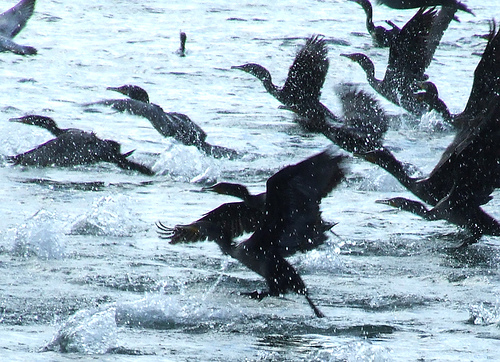Can you describe the overall activity of the birds in the water? The birds appear to be energetically interacting with the water, some are taking off into the air while others are diving or flapping their wings on the surface, creating a dynamic and lively scene. Can you zoom in on a single bird and describe its actions in detail? Upon focusing on a single bird, you can see it extends its wings wide while skimming across the water. The splashes around it suggest rapid movement, possibly as it prepares to lift off. Its feathers glisten with water droplets, and there is a sense of urgency and motion. The bird's posture suggests either an attempted takeoff or just having landed from a flight. Imagine this scene in a storm. How might it look? In the midst of a storm, this scene would transform dramatically. The calm ripples of water would be unruly waves, pounding and churning violently. The birds, struggling against the forceful gusts of wind, would be less coordinated, fighting to stay afloat or aloft. Their feathers would be plastered against their bodies, wet and heavy. Lightning might illuminate the chaotic scene intermittently, casting stark shadows and highlighting the power of nature against these resilient creatures. Thunder would drown out the cacophony of flapping wings and splashing water, creating a sense of awe and peril. Describe the journey of a single droplet from the water to landing on a bird. A single water droplet, shimmering under the sunlight, begins its journey as it is flung into the air by the force of a bird’s wings hitting the water's surface. It arcs through the air, catching reflections of the scene around it – the flapping wings, the rippling waves. As it travels, it joins countless others, creating a brief necklace of droplets that glint momentarily. This droplet’s path is chaotic, buffeted by winds and the movement of birds. As it reaches the zenith of its arc, it descends in a graceful parabola, striking the dark feathers of a bird below. Upon contact, it splashes into even smaller droplets, some absorbed by the bird’s plumage, others falling back to join the watery chaos below, completing a cycle of motion in this dynamic environment. 